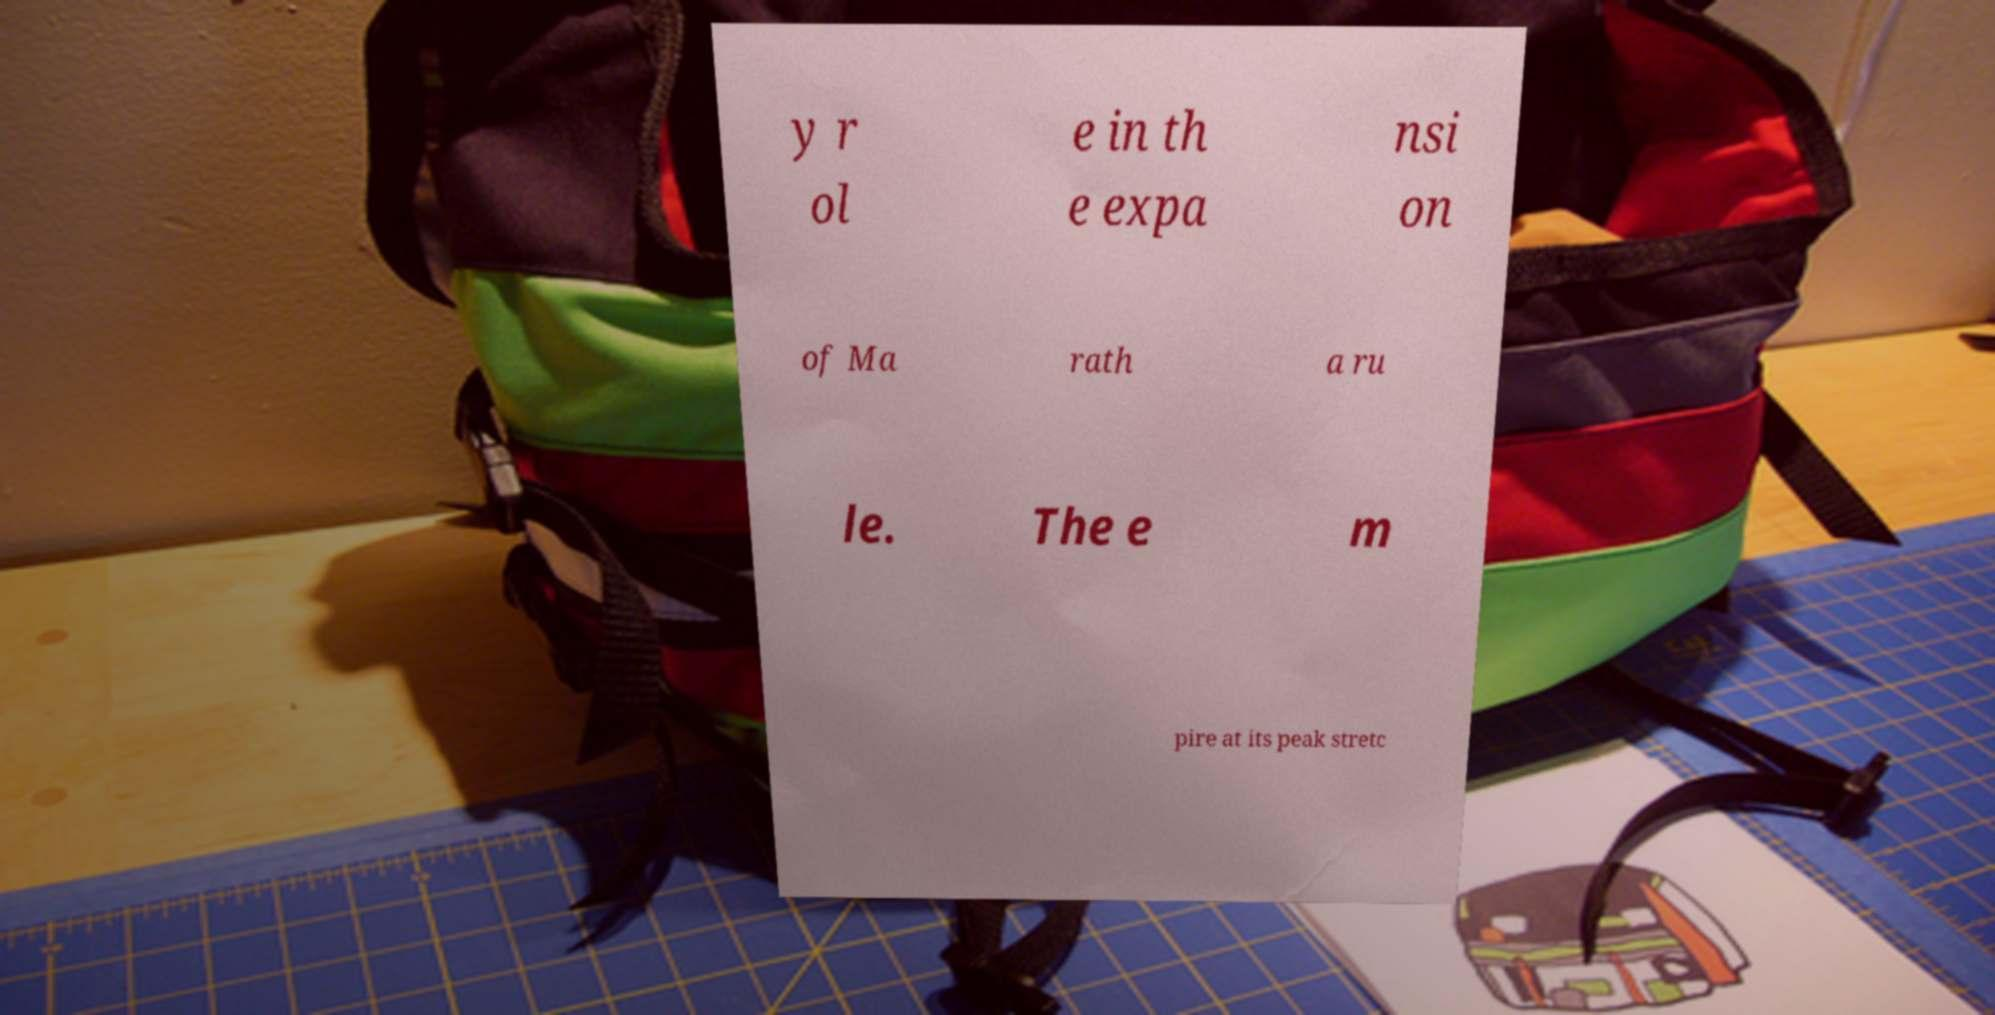There's text embedded in this image that I need extracted. Can you transcribe it verbatim? y r ol e in th e expa nsi on of Ma rath a ru le. The e m pire at its peak stretc 